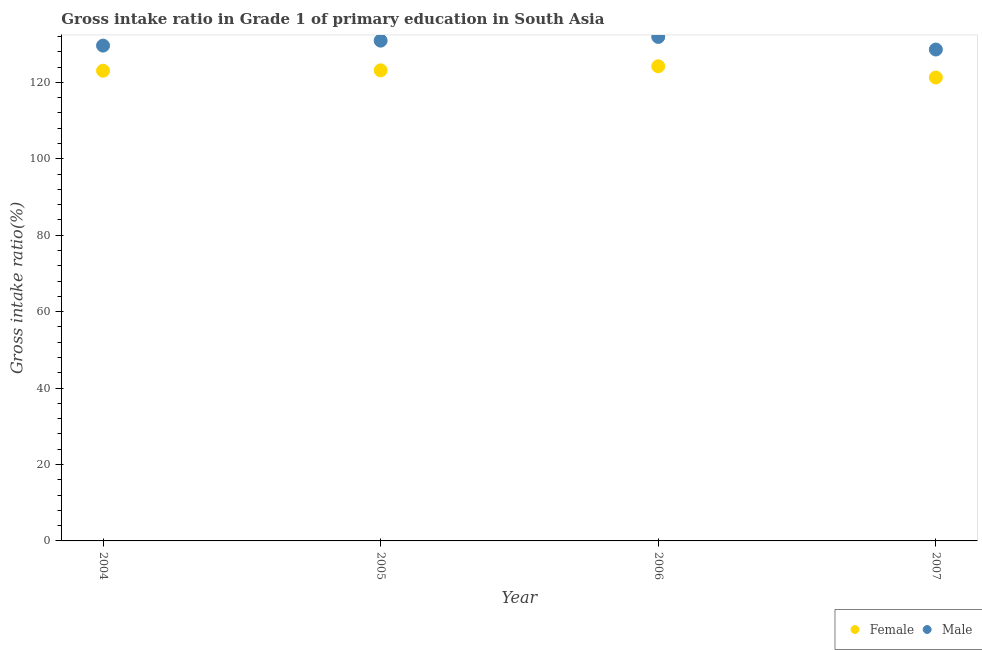How many different coloured dotlines are there?
Offer a very short reply. 2. What is the gross intake ratio(male) in 2007?
Offer a very short reply. 128.59. Across all years, what is the maximum gross intake ratio(female)?
Your answer should be compact. 124.21. Across all years, what is the minimum gross intake ratio(male)?
Ensure brevity in your answer.  128.59. What is the total gross intake ratio(female) in the graph?
Provide a succinct answer. 491.65. What is the difference between the gross intake ratio(male) in 2004 and that in 2007?
Give a very brief answer. 1.02. What is the difference between the gross intake ratio(male) in 2006 and the gross intake ratio(female) in 2005?
Your answer should be very brief. 8.75. What is the average gross intake ratio(female) per year?
Offer a terse response. 122.91. In the year 2004, what is the difference between the gross intake ratio(female) and gross intake ratio(male)?
Provide a short and direct response. -6.57. What is the ratio of the gross intake ratio(female) in 2005 to that in 2006?
Provide a short and direct response. 0.99. Is the gross intake ratio(male) in 2004 less than that in 2005?
Offer a terse response. Yes. Is the difference between the gross intake ratio(female) in 2006 and 2007 greater than the difference between the gross intake ratio(male) in 2006 and 2007?
Offer a very short reply. No. What is the difference between the highest and the second highest gross intake ratio(male)?
Provide a succinct answer. 0.98. What is the difference between the highest and the lowest gross intake ratio(female)?
Provide a succinct answer. 2.94. Is the gross intake ratio(male) strictly greater than the gross intake ratio(female) over the years?
Offer a very short reply. Yes. Is the gross intake ratio(female) strictly less than the gross intake ratio(male) over the years?
Ensure brevity in your answer.  Yes. How many dotlines are there?
Ensure brevity in your answer.  2. What is the difference between two consecutive major ticks on the Y-axis?
Your answer should be very brief. 20. Does the graph contain any zero values?
Your response must be concise. No. Does the graph contain grids?
Your answer should be very brief. No. What is the title of the graph?
Make the answer very short. Gross intake ratio in Grade 1 of primary education in South Asia. Does "RDB nonconcessional" appear as one of the legend labels in the graph?
Your response must be concise. No. What is the label or title of the Y-axis?
Make the answer very short. Gross intake ratio(%). What is the Gross intake ratio(%) in Female in 2004?
Your response must be concise. 123.04. What is the Gross intake ratio(%) of Male in 2004?
Make the answer very short. 129.61. What is the Gross intake ratio(%) in Female in 2005?
Your response must be concise. 123.14. What is the Gross intake ratio(%) in Male in 2005?
Give a very brief answer. 130.91. What is the Gross intake ratio(%) in Female in 2006?
Your answer should be very brief. 124.21. What is the Gross intake ratio(%) of Male in 2006?
Ensure brevity in your answer.  131.89. What is the Gross intake ratio(%) in Female in 2007?
Give a very brief answer. 121.26. What is the Gross intake ratio(%) in Male in 2007?
Offer a terse response. 128.59. Across all years, what is the maximum Gross intake ratio(%) of Female?
Your answer should be compact. 124.21. Across all years, what is the maximum Gross intake ratio(%) in Male?
Offer a terse response. 131.89. Across all years, what is the minimum Gross intake ratio(%) of Female?
Provide a short and direct response. 121.26. Across all years, what is the minimum Gross intake ratio(%) in Male?
Offer a terse response. 128.59. What is the total Gross intake ratio(%) in Female in the graph?
Your response must be concise. 491.65. What is the total Gross intake ratio(%) in Male in the graph?
Offer a very short reply. 521. What is the difference between the Gross intake ratio(%) in Female in 2004 and that in 2005?
Your answer should be compact. -0.1. What is the difference between the Gross intake ratio(%) of Male in 2004 and that in 2005?
Your answer should be very brief. -1.3. What is the difference between the Gross intake ratio(%) of Female in 2004 and that in 2006?
Your answer should be very brief. -1.16. What is the difference between the Gross intake ratio(%) in Male in 2004 and that in 2006?
Ensure brevity in your answer.  -2.28. What is the difference between the Gross intake ratio(%) of Female in 2004 and that in 2007?
Offer a very short reply. 1.78. What is the difference between the Gross intake ratio(%) of Male in 2004 and that in 2007?
Your answer should be very brief. 1.02. What is the difference between the Gross intake ratio(%) of Female in 2005 and that in 2006?
Your answer should be very brief. -1.06. What is the difference between the Gross intake ratio(%) of Male in 2005 and that in 2006?
Your answer should be compact. -0.98. What is the difference between the Gross intake ratio(%) in Female in 2005 and that in 2007?
Provide a succinct answer. 1.88. What is the difference between the Gross intake ratio(%) in Male in 2005 and that in 2007?
Your answer should be very brief. 2.32. What is the difference between the Gross intake ratio(%) in Female in 2006 and that in 2007?
Offer a terse response. 2.94. What is the difference between the Gross intake ratio(%) in Male in 2006 and that in 2007?
Offer a terse response. 3.3. What is the difference between the Gross intake ratio(%) of Female in 2004 and the Gross intake ratio(%) of Male in 2005?
Provide a succinct answer. -7.87. What is the difference between the Gross intake ratio(%) in Female in 2004 and the Gross intake ratio(%) in Male in 2006?
Your answer should be compact. -8.85. What is the difference between the Gross intake ratio(%) of Female in 2004 and the Gross intake ratio(%) of Male in 2007?
Provide a succinct answer. -5.55. What is the difference between the Gross intake ratio(%) of Female in 2005 and the Gross intake ratio(%) of Male in 2006?
Your answer should be very brief. -8.75. What is the difference between the Gross intake ratio(%) of Female in 2005 and the Gross intake ratio(%) of Male in 2007?
Give a very brief answer. -5.44. What is the difference between the Gross intake ratio(%) of Female in 2006 and the Gross intake ratio(%) of Male in 2007?
Make the answer very short. -4.38. What is the average Gross intake ratio(%) in Female per year?
Provide a succinct answer. 122.91. What is the average Gross intake ratio(%) in Male per year?
Keep it short and to the point. 130.25. In the year 2004, what is the difference between the Gross intake ratio(%) of Female and Gross intake ratio(%) of Male?
Your response must be concise. -6.57. In the year 2005, what is the difference between the Gross intake ratio(%) in Female and Gross intake ratio(%) in Male?
Your response must be concise. -7.77. In the year 2006, what is the difference between the Gross intake ratio(%) in Female and Gross intake ratio(%) in Male?
Provide a short and direct response. -7.68. In the year 2007, what is the difference between the Gross intake ratio(%) in Female and Gross intake ratio(%) in Male?
Your response must be concise. -7.32. What is the ratio of the Gross intake ratio(%) in Female in 2004 to that in 2006?
Your response must be concise. 0.99. What is the ratio of the Gross intake ratio(%) of Male in 2004 to that in 2006?
Provide a short and direct response. 0.98. What is the ratio of the Gross intake ratio(%) in Female in 2004 to that in 2007?
Give a very brief answer. 1.01. What is the ratio of the Gross intake ratio(%) of Male in 2005 to that in 2006?
Give a very brief answer. 0.99. What is the ratio of the Gross intake ratio(%) in Female in 2005 to that in 2007?
Your answer should be compact. 1.02. What is the ratio of the Gross intake ratio(%) of Male in 2005 to that in 2007?
Your response must be concise. 1.02. What is the ratio of the Gross intake ratio(%) in Female in 2006 to that in 2007?
Your response must be concise. 1.02. What is the ratio of the Gross intake ratio(%) in Male in 2006 to that in 2007?
Offer a very short reply. 1.03. What is the difference between the highest and the second highest Gross intake ratio(%) in Female?
Your answer should be compact. 1.06. What is the difference between the highest and the second highest Gross intake ratio(%) of Male?
Offer a terse response. 0.98. What is the difference between the highest and the lowest Gross intake ratio(%) in Female?
Give a very brief answer. 2.94. What is the difference between the highest and the lowest Gross intake ratio(%) of Male?
Keep it short and to the point. 3.3. 